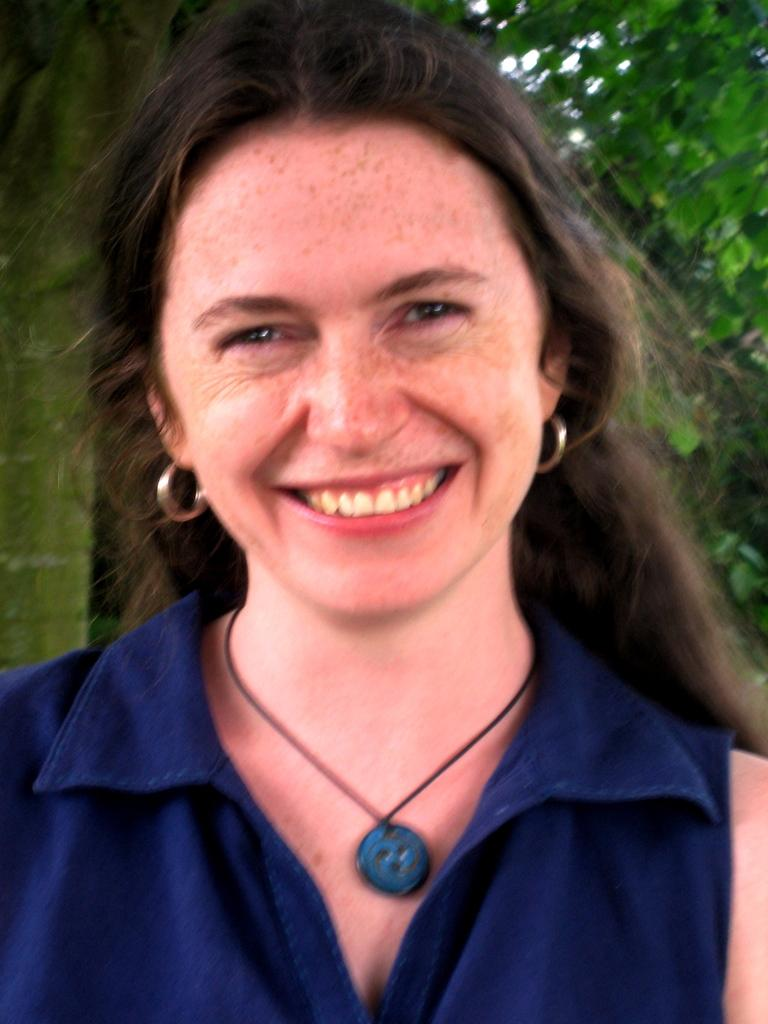Who is present in the image? There is a woman in the image. What is the woman's facial expression? The woman is smiling. What can be seen in the background of the image? Trees and the sky are visible in the background of the image. Is there a basin of water in the image? There is no basin of water present in the image. Can you tell me how deep the quicksand is in the image? There is no quicksand present in the image. 